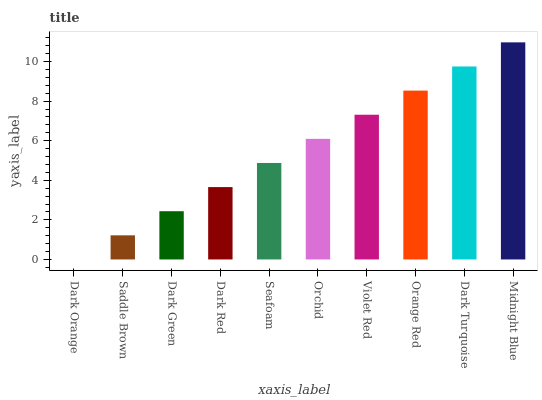Is Saddle Brown the minimum?
Answer yes or no. No. Is Saddle Brown the maximum?
Answer yes or no. No. Is Saddle Brown greater than Dark Orange?
Answer yes or no. Yes. Is Dark Orange less than Saddle Brown?
Answer yes or no. Yes. Is Dark Orange greater than Saddle Brown?
Answer yes or no. No. Is Saddle Brown less than Dark Orange?
Answer yes or no. No. Is Orchid the high median?
Answer yes or no. Yes. Is Seafoam the low median?
Answer yes or no. Yes. Is Saddle Brown the high median?
Answer yes or no. No. Is Violet Red the low median?
Answer yes or no. No. 